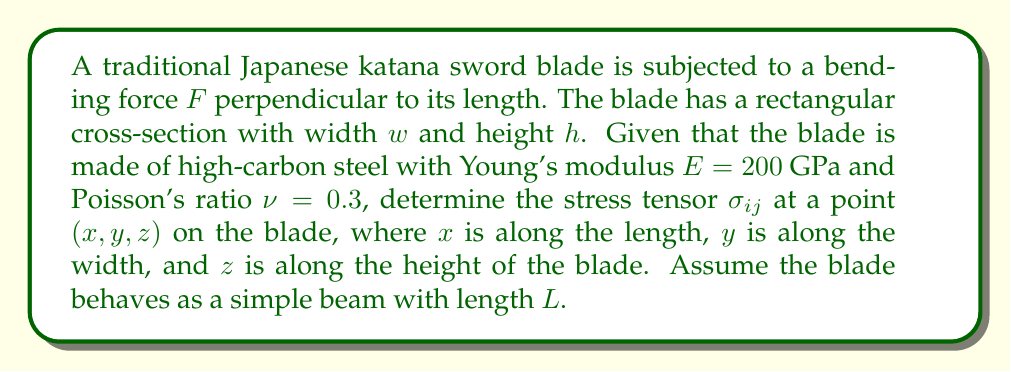Teach me how to tackle this problem. To determine the stress tensor in the katana blade, we'll follow these steps:

1. Calculate the moment of inertia $I$ for the rectangular cross-section:
   $$I = \frac{1}{12}wh^3$$

2. The bending moment $M$ at any point $x$ along the blade is:
   $$M(x) = F(L-x)$$

3. The normal stress $\sigma_{xx}$ due to bending is:
   $$\sigma_{xx} = -\frac{Mz}{I} = -\frac{F(L-x)z}{I}$$

4. The shear stress $\tau_{xz}$ is:
   $$\tau_{xz} = \frac{F}{2I}\left(\frac{h^2}{4} - z^2\right)$$

5. All other stress components are zero for simple beam bending.

6. The full stress tensor in matrix form is:
   $$\sigma_{ij} = \begin{bmatrix}
   \sigma_{xx} & 0 & \tau_{xz} \\
   0 & 0 & 0 \\
   \tau_{xz} & 0 & 0
   \end{bmatrix}$$

7. Substituting the expressions for $\sigma_{xx}$ and $\tau_{xz}$:
   $$\sigma_{ij} = \begin{bmatrix}
   -\frac{F(L-x)z}{I} & 0 & \frac{F}{2I}\left(\frac{h^2}{4} - z^2\right) \\
   0 & 0 & 0 \\
   \frac{F}{2I}\left(\frac{h^2}{4} - z^2\right) & 0 & 0
   \end{bmatrix}$$

This stress tensor represents the state of stress at any point $(x, y, z)$ in the katana blade under the given bending force.
Answer: $$\sigma_{ij} = \begin{bmatrix}
-\frac{F(L-x)z}{I} & 0 & \frac{F}{2I}\left(\frac{h^2}{4} - z^2\right) \\
0 & 0 & 0 \\
\frac{F}{2I}\left(\frac{h^2}{4} - z^2\right) & 0 & 0
\end{bmatrix}$$
where $I = \frac{1}{12}wh^3$ 